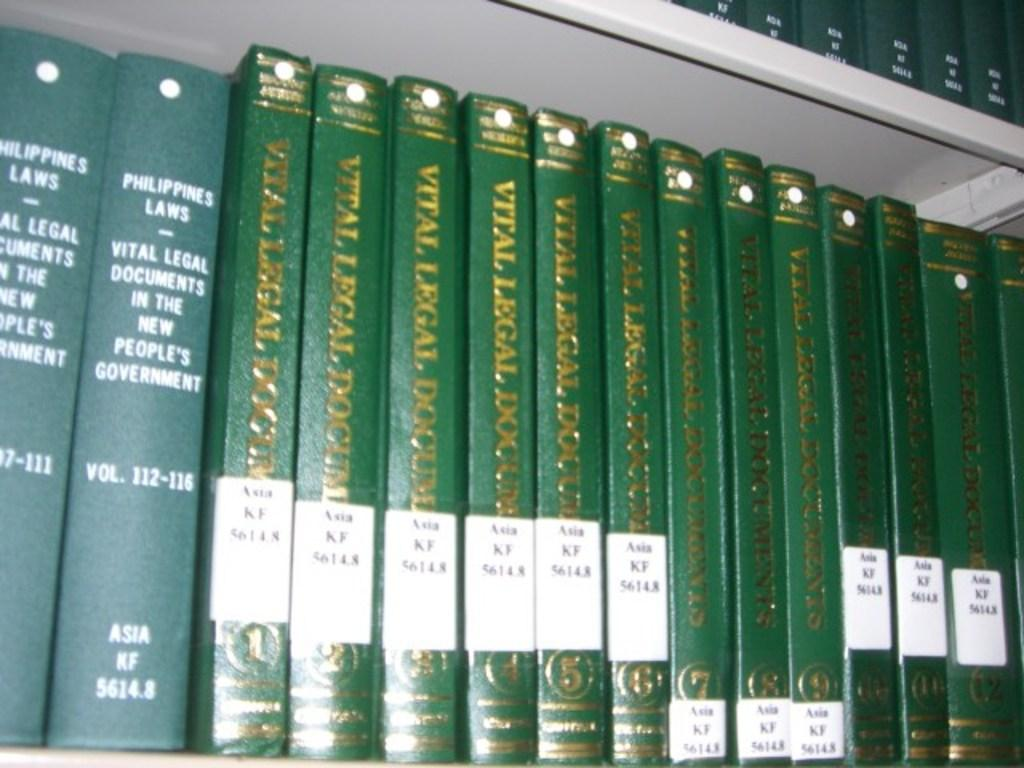Provide a one-sentence caption for the provided image. Vital legal documents books lined up on a bookshelf. 